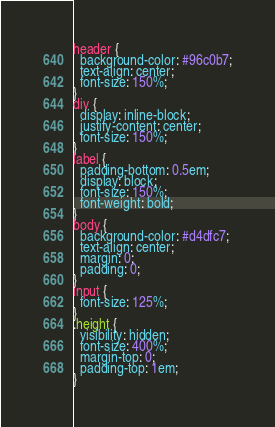<code> <loc_0><loc_0><loc_500><loc_500><_CSS_>header {
  background-color: #96c0b7;
  text-align: center;
  font-size: 150%;
}
div {
  display: inline-block;
  justify-content: center;
  font-size: 150%;
}
label {
  padding-bottom: 0.5em;
  display: block;
  font-size: 150%;
  font-weight: bold;
}
body {
  background-color: #d4dfc7;
  text-align: center;
  margin: 0;
  padding: 0;
}
input {
  font-size: 125%;
}
.height {
  visibility: hidden;
  font-size: 400%;
  margin-top: 0;
  padding-top: 1em;
}
</code> 